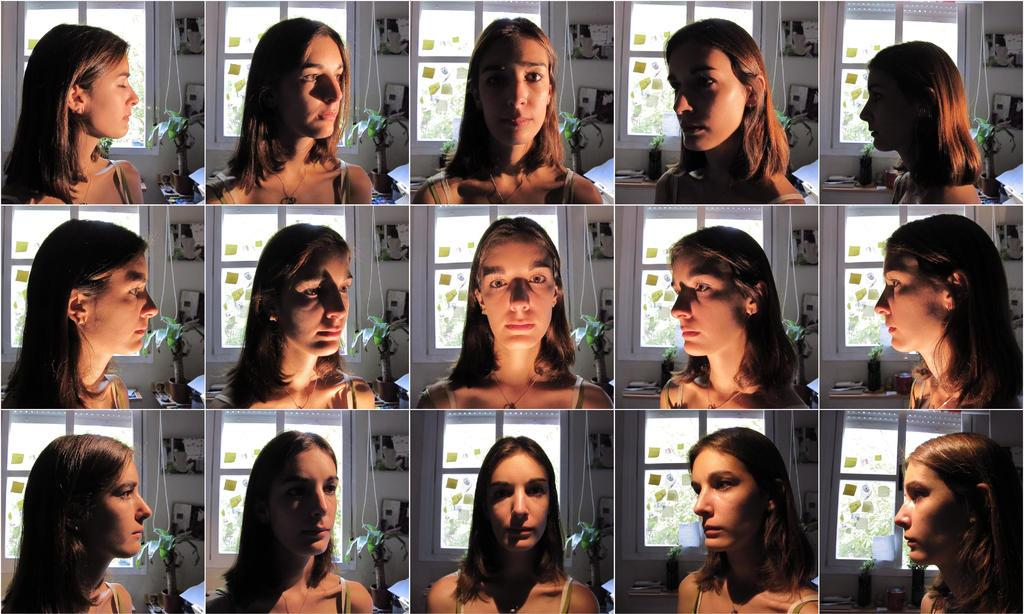What is the main subject of the image? There is a collage of a picture of a lady in the image. Can you describe the collage in more detail? The collage consists of a picture of a lady. What type of door can be seen in the collage? There is no door present in the collage; it only features a picture of a lady. What sound does the wax make in the image? There is no wax or sound present in the image; it only contains a collage of a picture of a lady. 